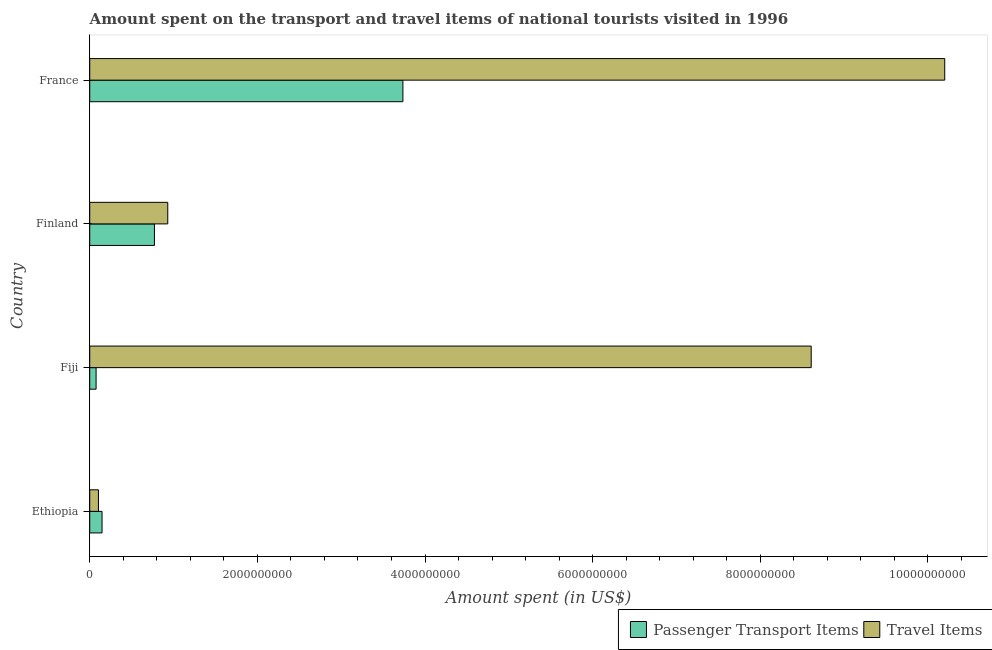How many different coloured bars are there?
Your response must be concise. 2. Are the number of bars per tick equal to the number of legend labels?
Give a very brief answer. Yes. How many bars are there on the 4th tick from the top?
Your answer should be very brief. 2. What is the label of the 1st group of bars from the top?
Ensure brevity in your answer.  France. What is the amount spent on passenger transport items in Finland?
Provide a succinct answer. 7.72e+08. Across all countries, what is the maximum amount spent in travel items?
Offer a terse response. 1.02e+1. Across all countries, what is the minimum amount spent in travel items?
Your response must be concise. 1.04e+08. In which country was the amount spent on passenger transport items maximum?
Your answer should be compact. France. In which country was the amount spent in travel items minimum?
Give a very brief answer. Ethiopia. What is the total amount spent in travel items in the graph?
Ensure brevity in your answer.  1.98e+1. What is the difference between the amount spent on passenger transport items in Finland and that in France?
Keep it short and to the point. -2.96e+09. What is the difference between the amount spent on passenger transport items in Fiji and the amount spent in travel items in Ethiopia?
Keep it short and to the point. -2.80e+07. What is the average amount spent in travel items per country?
Give a very brief answer. 4.96e+09. What is the difference between the amount spent on passenger transport items and amount spent in travel items in France?
Keep it short and to the point. -6.46e+09. In how many countries, is the amount spent in travel items greater than 6800000000 US$?
Your response must be concise. 2. What is the ratio of the amount spent in travel items in Finland to that in France?
Your answer should be very brief. 0.09. Is the amount spent in travel items in Ethiopia less than that in France?
Your answer should be compact. Yes. Is the difference between the amount spent on passenger transport items in Ethiopia and Finland greater than the difference between the amount spent in travel items in Ethiopia and Finland?
Make the answer very short. Yes. What is the difference between the highest and the second highest amount spent in travel items?
Offer a very short reply. 1.59e+09. What is the difference between the highest and the lowest amount spent in travel items?
Ensure brevity in your answer.  1.01e+1. In how many countries, is the amount spent on passenger transport items greater than the average amount spent on passenger transport items taken over all countries?
Your response must be concise. 1. Is the sum of the amount spent on passenger transport items in Fiji and France greater than the maximum amount spent in travel items across all countries?
Your answer should be very brief. No. What does the 2nd bar from the top in Ethiopia represents?
Your answer should be compact. Passenger Transport Items. What does the 1st bar from the bottom in France represents?
Your response must be concise. Passenger Transport Items. Are all the bars in the graph horizontal?
Offer a terse response. Yes. How many countries are there in the graph?
Your answer should be very brief. 4. What is the difference between two consecutive major ticks on the X-axis?
Ensure brevity in your answer.  2.00e+09. Does the graph contain any zero values?
Your answer should be compact. No. Does the graph contain grids?
Keep it short and to the point. No. What is the title of the graph?
Offer a very short reply. Amount spent on the transport and travel items of national tourists visited in 1996. What is the label or title of the X-axis?
Your answer should be very brief. Amount spent (in US$). What is the label or title of the Y-axis?
Ensure brevity in your answer.  Country. What is the Amount spent (in US$) of Passenger Transport Items in Ethiopia?
Your response must be concise. 1.47e+08. What is the Amount spent (in US$) of Travel Items in Ethiopia?
Offer a very short reply. 1.04e+08. What is the Amount spent (in US$) in Passenger Transport Items in Fiji?
Offer a very short reply. 7.60e+07. What is the Amount spent (in US$) of Travel Items in Fiji?
Your answer should be compact. 8.61e+09. What is the Amount spent (in US$) in Passenger Transport Items in Finland?
Your answer should be very brief. 7.72e+08. What is the Amount spent (in US$) in Travel Items in Finland?
Make the answer very short. 9.31e+08. What is the Amount spent (in US$) in Passenger Transport Items in France?
Your answer should be compact. 3.74e+09. What is the Amount spent (in US$) of Travel Items in France?
Offer a terse response. 1.02e+1. Across all countries, what is the maximum Amount spent (in US$) of Passenger Transport Items?
Your answer should be very brief. 3.74e+09. Across all countries, what is the maximum Amount spent (in US$) of Travel Items?
Your answer should be very brief. 1.02e+1. Across all countries, what is the minimum Amount spent (in US$) of Passenger Transport Items?
Your response must be concise. 7.60e+07. Across all countries, what is the minimum Amount spent (in US$) of Travel Items?
Keep it short and to the point. 1.04e+08. What is the total Amount spent (in US$) in Passenger Transport Items in the graph?
Provide a succinct answer. 4.73e+09. What is the total Amount spent (in US$) in Travel Items in the graph?
Your response must be concise. 1.98e+1. What is the difference between the Amount spent (in US$) of Passenger Transport Items in Ethiopia and that in Fiji?
Keep it short and to the point. 7.10e+07. What is the difference between the Amount spent (in US$) in Travel Items in Ethiopia and that in Fiji?
Provide a succinct answer. -8.50e+09. What is the difference between the Amount spent (in US$) in Passenger Transport Items in Ethiopia and that in Finland?
Provide a succinct answer. -6.25e+08. What is the difference between the Amount spent (in US$) in Travel Items in Ethiopia and that in Finland?
Offer a very short reply. -8.27e+08. What is the difference between the Amount spent (in US$) of Passenger Transport Items in Ethiopia and that in France?
Offer a terse response. -3.59e+09. What is the difference between the Amount spent (in US$) of Travel Items in Ethiopia and that in France?
Ensure brevity in your answer.  -1.01e+1. What is the difference between the Amount spent (in US$) of Passenger Transport Items in Fiji and that in Finland?
Provide a succinct answer. -6.96e+08. What is the difference between the Amount spent (in US$) in Travel Items in Fiji and that in Finland?
Your answer should be compact. 7.68e+09. What is the difference between the Amount spent (in US$) in Passenger Transport Items in Fiji and that in France?
Make the answer very short. -3.66e+09. What is the difference between the Amount spent (in US$) of Travel Items in Fiji and that in France?
Provide a short and direct response. -1.59e+09. What is the difference between the Amount spent (in US$) of Passenger Transport Items in Finland and that in France?
Provide a short and direct response. -2.96e+09. What is the difference between the Amount spent (in US$) in Travel Items in Finland and that in France?
Offer a terse response. -9.27e+09. What is the difference between the Amount spent (in US$) of Passenger Transport Items in Ethiopia and the Amount spent (in US$) of Travel Items in Fiji?
Keep it short and to the point. -8.46e+09. What is the difference between the Amount spent (in US$) in Passenger Transport Items in Ethiopia and the Amount spent (in US$) in Travel Items in Finland?
Provide a short and direct response. -7.84e+08. What is the difference between the Amount spent (in US$) of Passenger Transport Items in Ethiopia and the Amount spent (in US$) of Travel Items in France?
Your response must be concise. -1.01e+1. What is the difference between the Amount spent (in US$) in Passenger Transport Items in Fiji and the Amount spent (in US$) in Travel Items in Finland?
Offer a terse response. -8.55e+08. What is the difference between the Amount spent (in US$) in Passenger Transport Items in Fiji and the Amount spent (in US$) in Travel Items in France?
Provide a short and direct response. -1.01e+1. What is the difference between the Amount spent (in US$) in Passenger Transport Items in Finland and the Amount spent (in US$) in Travel Items in France?
Ensure brevity in your answer.  -9.43e+09. What is the average Amount spent (in US$) in Passenger Transport Items per country?
Offer a terse response. 1.18e+09. What is the average Amount spent (in US$) of Travel Items per country?
Give a very brief answer. 4.96e+09. What is the difference between the Amount spent (in US$) in Passenger Transport Items and Amount spent (in US$) in Travel Items in Ethiopia?
Your answer should be compact. 4.30e+07. What is the difference between the Amount spent (in US$) of Passenger Transport Items and Amount spent (in US$) of Travel Items in Fiji?
Offer a very short reply. -8.53e+09. What is the difference between the Amount spent (in US$) of Passenger Transport Items and Amount spent (in US$) of Travel Items in Finland?
Keep it short and to the point. -1.59e+08. What is the difference between the Amount spent (in US$) of Passenger Transport Items and Amount spent (in US$) of Travel Items in France?
Your answer should be very brief. -6.46e+09. What is the ratio of the Amount spent (in US$) in Passenger Transport Items in Ethiopia to that in Fiji?
Provide a succinct answer. 1.93. What is the ratio of the Amount spent (in US$) in Travel Items in Ethiopia to that in Fiji?
Your answer should be compact. 0.01. What is the ratio of the Amount spent (in US$) of Passenger Transport Items in Ethiopia to that in Finland?
Provide a succinct answer. 0.19. What is the ratio of the Amount spent (in US$) of Travel Items in Ethiopia to that in Finland?
Keep it short and to the point. 0.11. What is the ratio of the Amount spent (in US$) of Passenger Transport Items in Ethiopia to that in France?
Offer a very short reply. 0.04. What is the ratio of the Amount spent (in US$) in Travel Items in Ethiopia to that in France?
Offer a terse response. 0.01. What is the ratio of the Amount spent (in US$) of Passenger Transport Items in Fiji to that in Finland?
Provide a short and direct response. 0.1. What is the ratio of the Amount spent (in US$) in Travel Items in Fiji to that in Finland?
Provide a short and direct response. 9.24. What is the ratio of the Amount spent (in US$) in Passenger Transport Items in Fiji to that in France?
Provide a short and direct response. 0.02. What is the ratio of the Amount spent (in US$) of Travel Items in Fiji to that in France?
Provide a short and direct response. 0.84. What is the ratio of the Amount spent (in US$) of Passenger Transport Items in Finland to that in France?
Keep it short and to the point. 0.21. What is the ratio of the Amount spent (in US$) of Travel Items in Finland to that in France?
Provide a succinct answer. 0.09. What is the difference between the highest and the second highest Amount spent (in US$) of Passenger Transport Items?
Ensure brevity in your answer.  2.96e+09. What is the difference between the highest and the second highest Amount spent (in US$) in Travel Items?
Your answer should be very brief. 1.59e+09. What is the difference between the highest and the lowest Amount spent (in US$) in Passenger Transport Items?
Give a very brief answer. 3.66e+09. What is the difference between the highest and the lowest Amount spent (in US$) of Travel Items?
Give a very brief answer. 1.01e+1. 